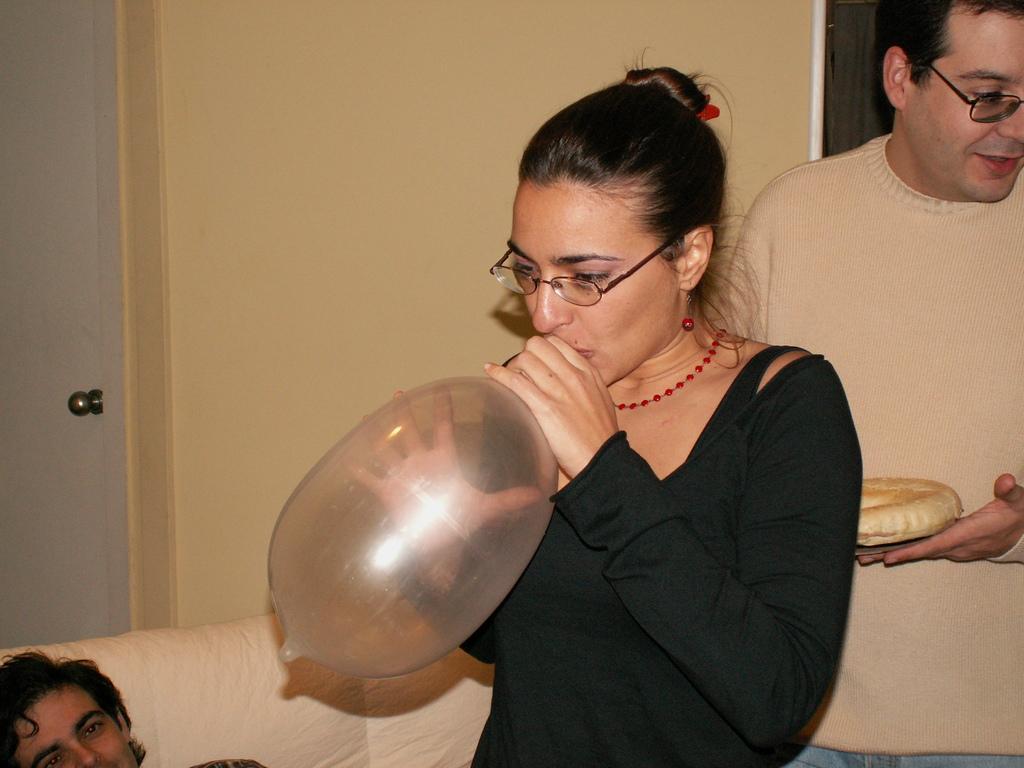Describe this image in one or two sentences. In this image, we can see three people. Here a woman is blowing a balloon. On the right side, a person is holding some food item in his hand. These people are wearing glasses. At the bottom, we can see a white couch. Background there is a wall, door, handle. 